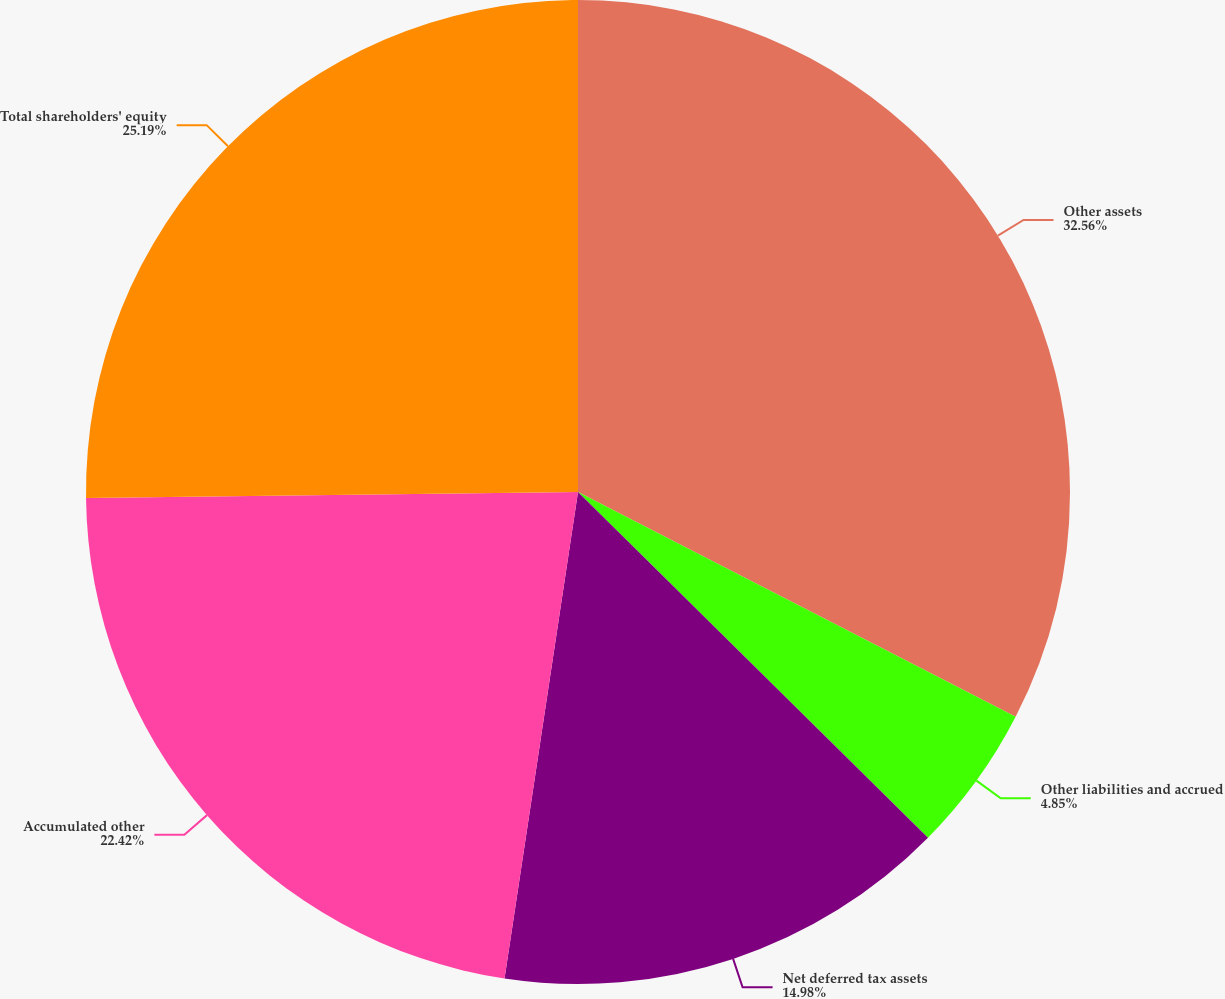Convert chart to OTSL. <chart><loc_0><loc_0><loc_500><loc_500><pie_chart><fcel>Other assets<fcel>Other liabilities and accrued<fcel>Net deferred tax assets<fcel>Accumulated other<fcel>Total shareholders' equity<nl><fcel>32.55%<fcel>4.85%<fcel>14.98%<fcel>22.42%<fcel>25.19%<nl></chart> 